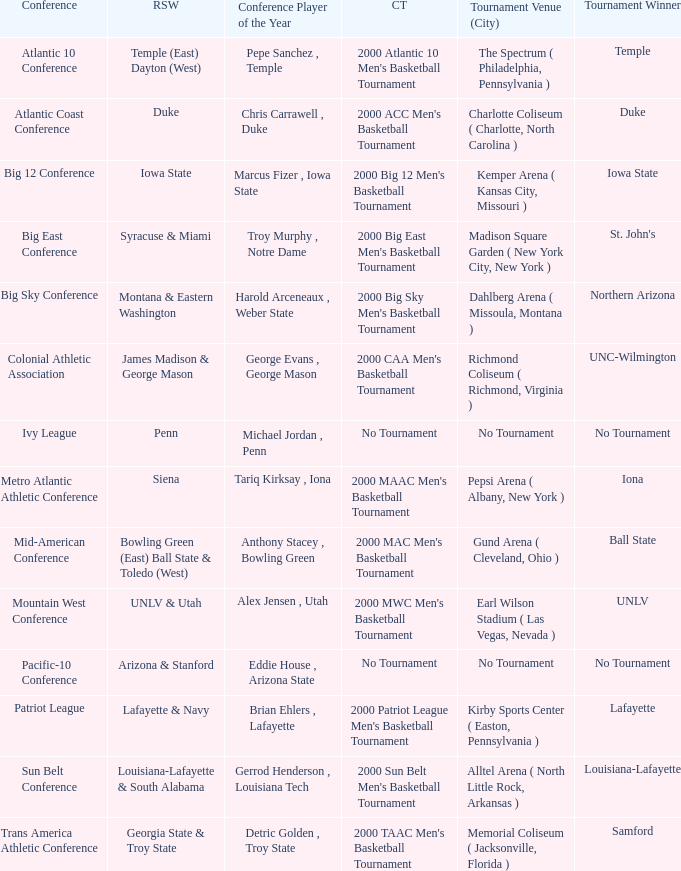Who is the conference Player of the Year in the conference where Lafayette won the tournament? Brian Ehlers , Lafayette. 